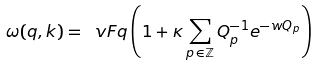Convert formula to latex. <formula><loc_0><loc_0><loc_500><loc_500>\omega ( q , k ) = \ v F q \left ( 1 + \kappa \sum _ { p \, \in \mathbb { Z } } Q _ { p } ^ { - 1 } e ^ { - w Q _ { p } } \right )</formula> 